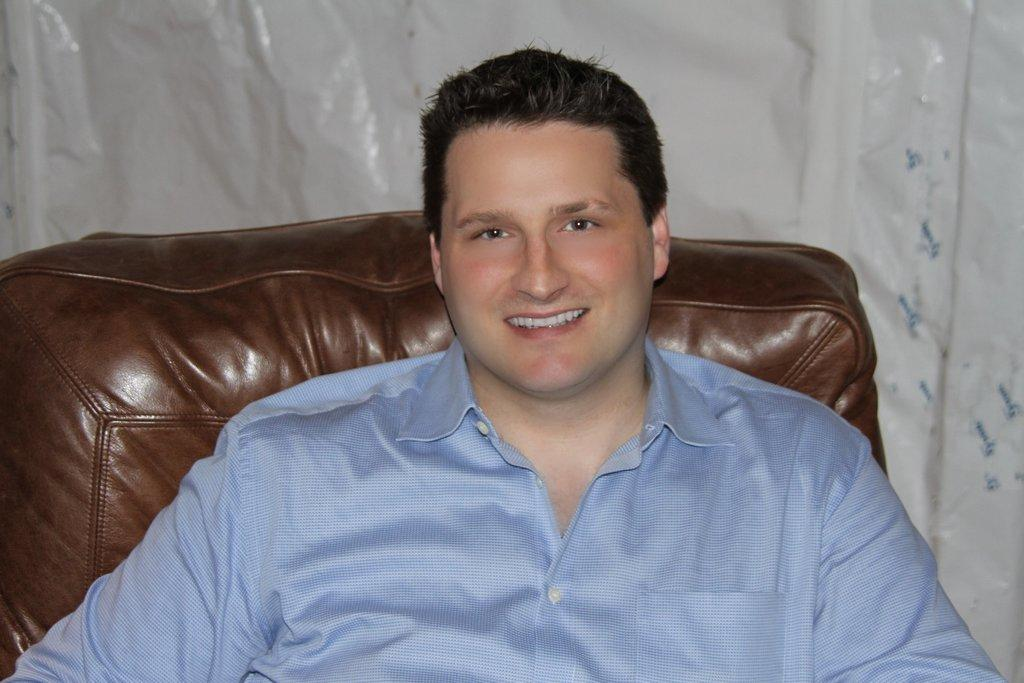What is the main subject in the foreground of the picture? There is a person sitting in a couch in the foreground of the picture. Can you describe the object in the background of the picture? There is a white color object in the background of the picture. What type of event is happening with the clam in the picture? There is no clam present in the picture, so it is not possible to answer that question. 